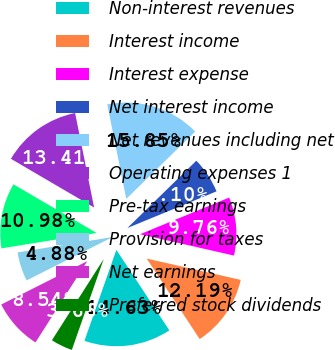Convert chart. <chart><loc_0><loc_0><loc_500><loc_500><pie_chart><fcel>Non-interest revenues<fcel>Interest income<fcel>Interest expense<fcel>Net interest income<fcel>Net revenues including net<fcel>Operating expenses 1<fcel>Pre-tax earnings<fcel>Provision for taxes<fcel>Net earnings<fcel>Preferred stock dividends<nl><fcel>14.63%<fcel>12.19%<fcel>9.76%<fcel>6.1%<fcel>15.85%<fcel>13.41%<fcel>10.98%<fcel>4.88%<fcel>8.54%<fcel>3.66%<nl></chart> 